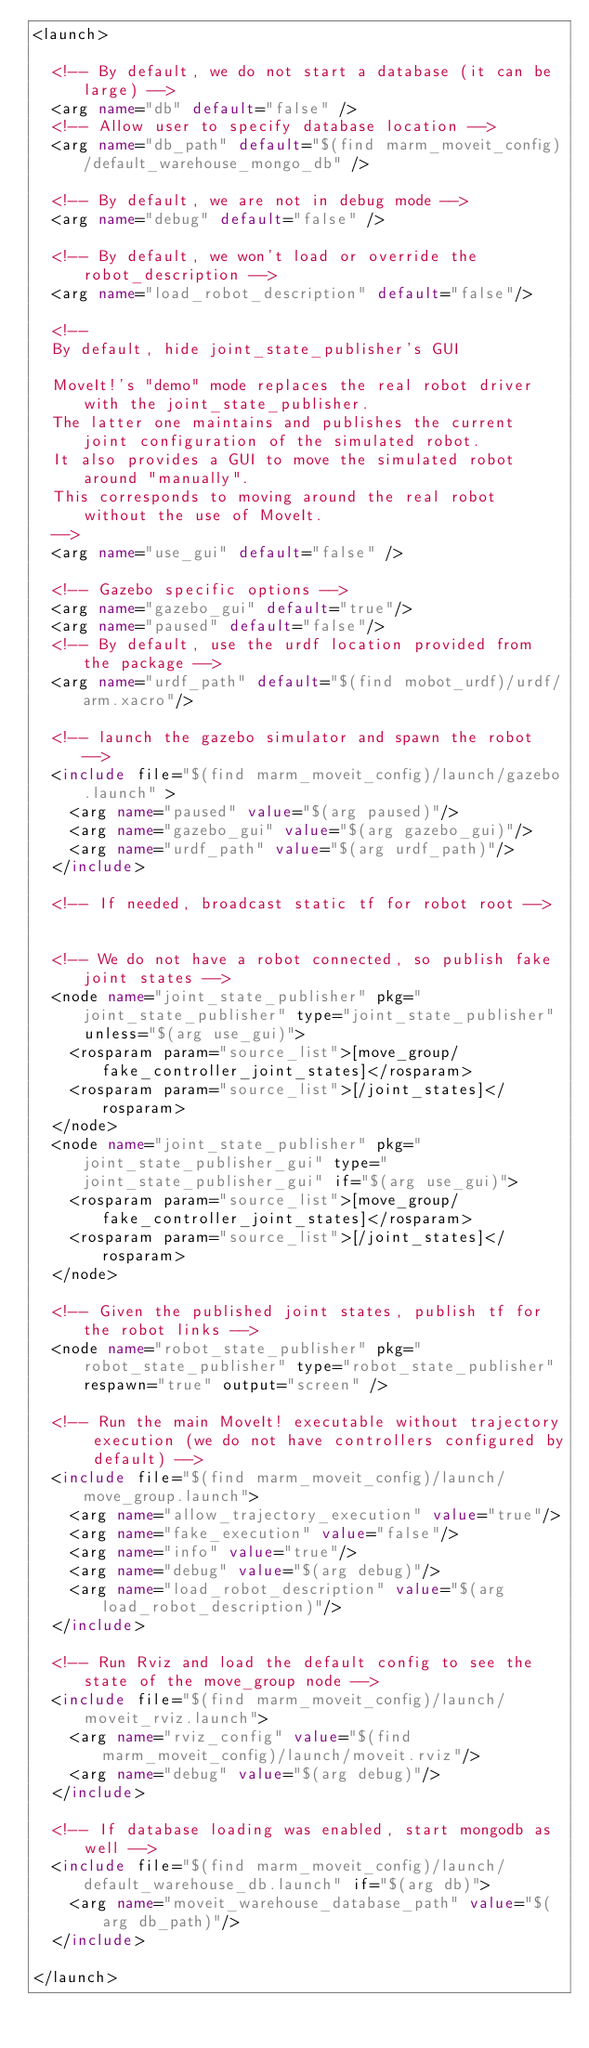<code> <loc_0><loc_0><loc_500><loc_500><_XML_><launch>

  <!-- By default, we do not start a database (it can be large) -->
  <arg name="db" default="false" />
  <!-- Allow user to specify database location -->
  <arg name="db_path" default="$(find marm_moveit_config)/default_warehouse_mongo_db" />

  <!-- By default, we are not in debug mode -->
  <arg name="debug" default="false" />

  <!-- By default, we won't load or override the robot_description -->
  <arg name="load_robot_description" default="false"/>

  <!--
  By default, hide joint_state_publisher's GUI

  MoveIt!'s "demo" mode replaces the real robot driver with the joint_state_publisher.
  The latter one maintains and publishes the current joint configuration of the simulated robot.
  It also provides a GUI to move the simulated robot around "manually".
  This corresponds to moving around the real robot without the use of MoveIt.
  -->
  <arg name="use_gui" default="false" />

  <!-- Gazebo specific options -->
  <arg name="gazebo_gui" default="true"/>
  <arg name="paused" default="false"/>
  <!-- By default, use the urdf location provided from the package -->
  <arg name="urdf_path" default="$(find mobot_urdf)/urdf/arm.xacro"/>

  <!-- launch the gazebo simulator and spawn the robot -->
  <include file="$(find marm_moveit_config)/launch/gazebo.launch" >
    <arg name="paused" value="$(arg paused)"/>
    <arg name="gazebo_gui" value="$(arg gazebo_gui)"/>
    <arg name="urdf_path" value="$(arg urdf_path)"/>
  </include>

  <!-- If needed, broadcast static tf for robot root -->
  

  <!-- We do not have a robot connected, so publish fake joint states -->
  <node name="joint_state_publisher" pkg="joint_state_publisher" type="joint_state_publisher" unless="$(arg use_gui)">
    <rosparam param="source_list">[move_group/fake_controller_joint_states]</rosparam>
    <rosparam param="source_list">[/joint_states]</rosparam>
  </node>
  <node name="joint_state_publisher" pkg="joint_state_publisher_gui" type="joint_state_publisher_gui" if="$(arg use_gui)">
    <rosparam param="source_list">[move_group/fake_controller_joint_states]</rosparam>
    <rosparam param="source_list">[/joint_states]</rosparam>
  </node>

  <!-- Given the published joint states, publish tf for the robot links -->
  <node name="robot_state_publisher" pkg="robot_state_publisher" type="robot_state_publisher" respawn="true" output="screen" />

  <!-- Run the main MoveIt! executable without trajectory execution (we do not have controllers configured by default) -->
  <include file="$(find marm_moveit_config)/launch/move_group.launch">
    <arg name="allow_trajectory_execution" value="true"/>
    <arg name="fake_execution" value="false"/>
    <arg name="info" value="true"/>
    <arg name="debug" value="$(arg debug)"/>
    <arg name="load_robot_description" value="$(arg load_robot_description)"/>
  </include>

  <!-- Run Rviz and load the default config to see the state of the move_group node -->
  <include file="$(find marm_moveit_config)/launch/moveit_rviz.launch">
    <arg name="rviz_config" value="$(find marm_moveit_config)/launch/moveit.rviz"/>
    <arg name="debug" value="$(arg debug)"/>
  </include>

  <!-- If database loading was enabled, start mongodb as well -->
  <include file="$(find marm_moveit_config)/launch/default_warehouse_db.launch" if="$(arg db)">
    <arg name="moveit_warehouse_database_path" value="$(arg db_path)"/>
  </include>

</launch>
</code> 